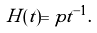<formula> <loc_0><loc_0><loc_500><loc_500>H ( t ) = p t ^ { - 1 } .</formula> 